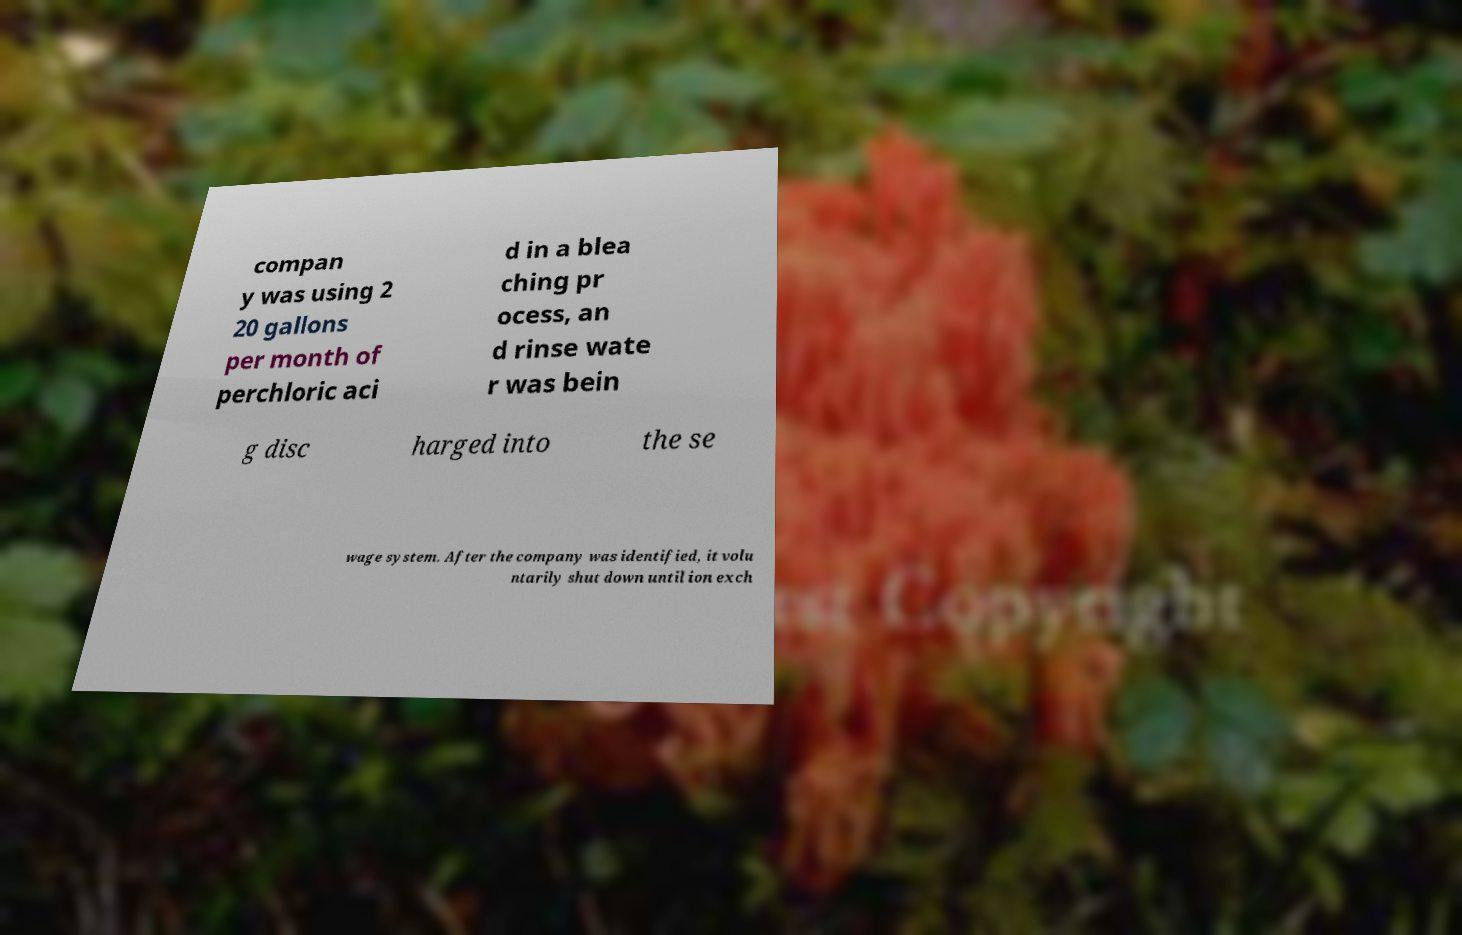Please identify and transcribe the text found in this image. compan y was using 2 20 gallons per month of perchloric aci d in a blea ching pr ocess, an d rinse wate r was bein g disc harged into the se wage system. After the company was identified, it volu ntarily shut down until ion exch 